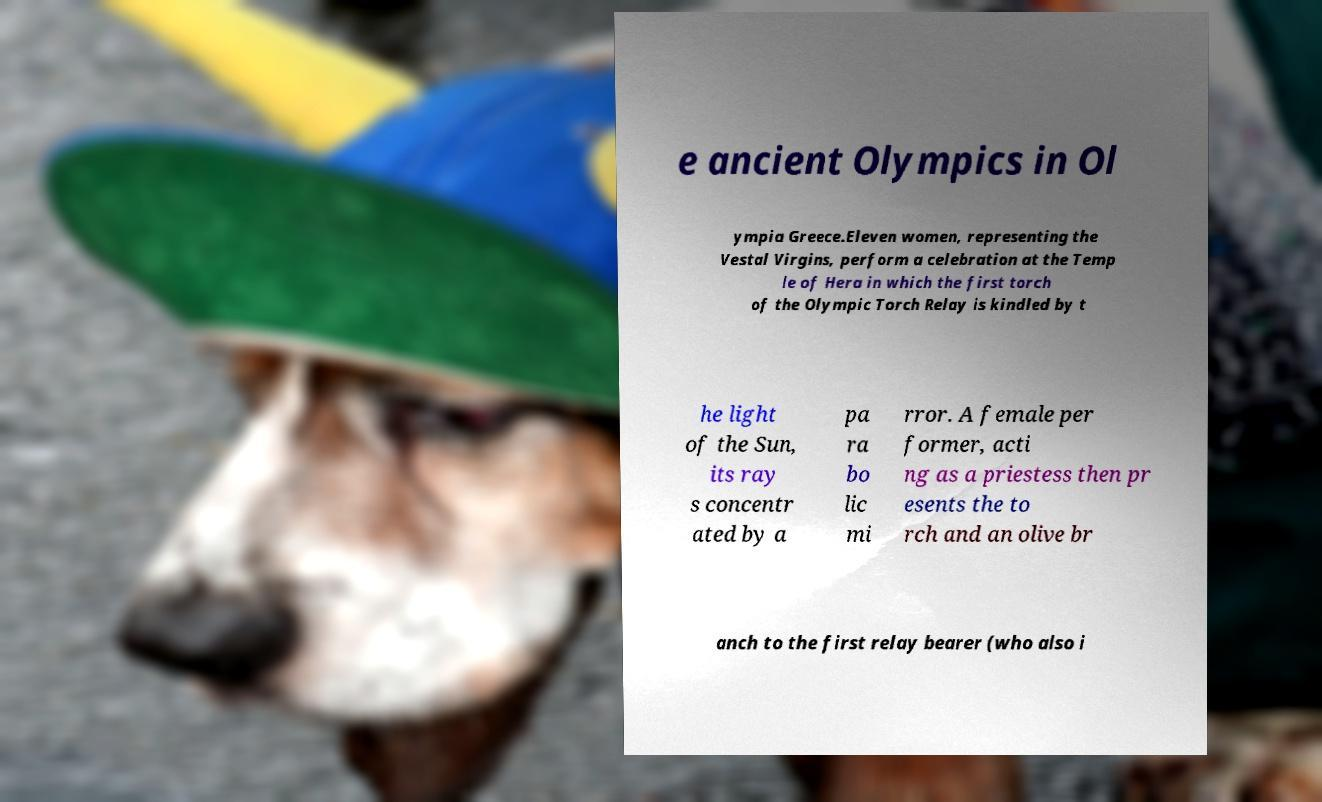What messages or text are displayed in this image? I need them in a readable, typed format. e ancient Olympics in Ol ympia Greece.Eleven women, representing the Vestal Virgins, perform a celebration at the Temp le of Hera in which the first torch of the Olympic Torch Relay is kindled by t he light of the Sun, its ray s concentr ated by a pa ra bo lic mi rror. A female per former, acti ng as a priestess then pr esents the to rch and an olive br anch to the first relay bearer (who also i 